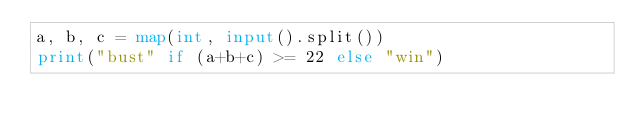<code> <loc_0><loc_0><loc_500><loc_500><_Python_>a, b, c = map(int, input().split())
print("bust" if (a+b+c) >= 22 else "win")</code> 